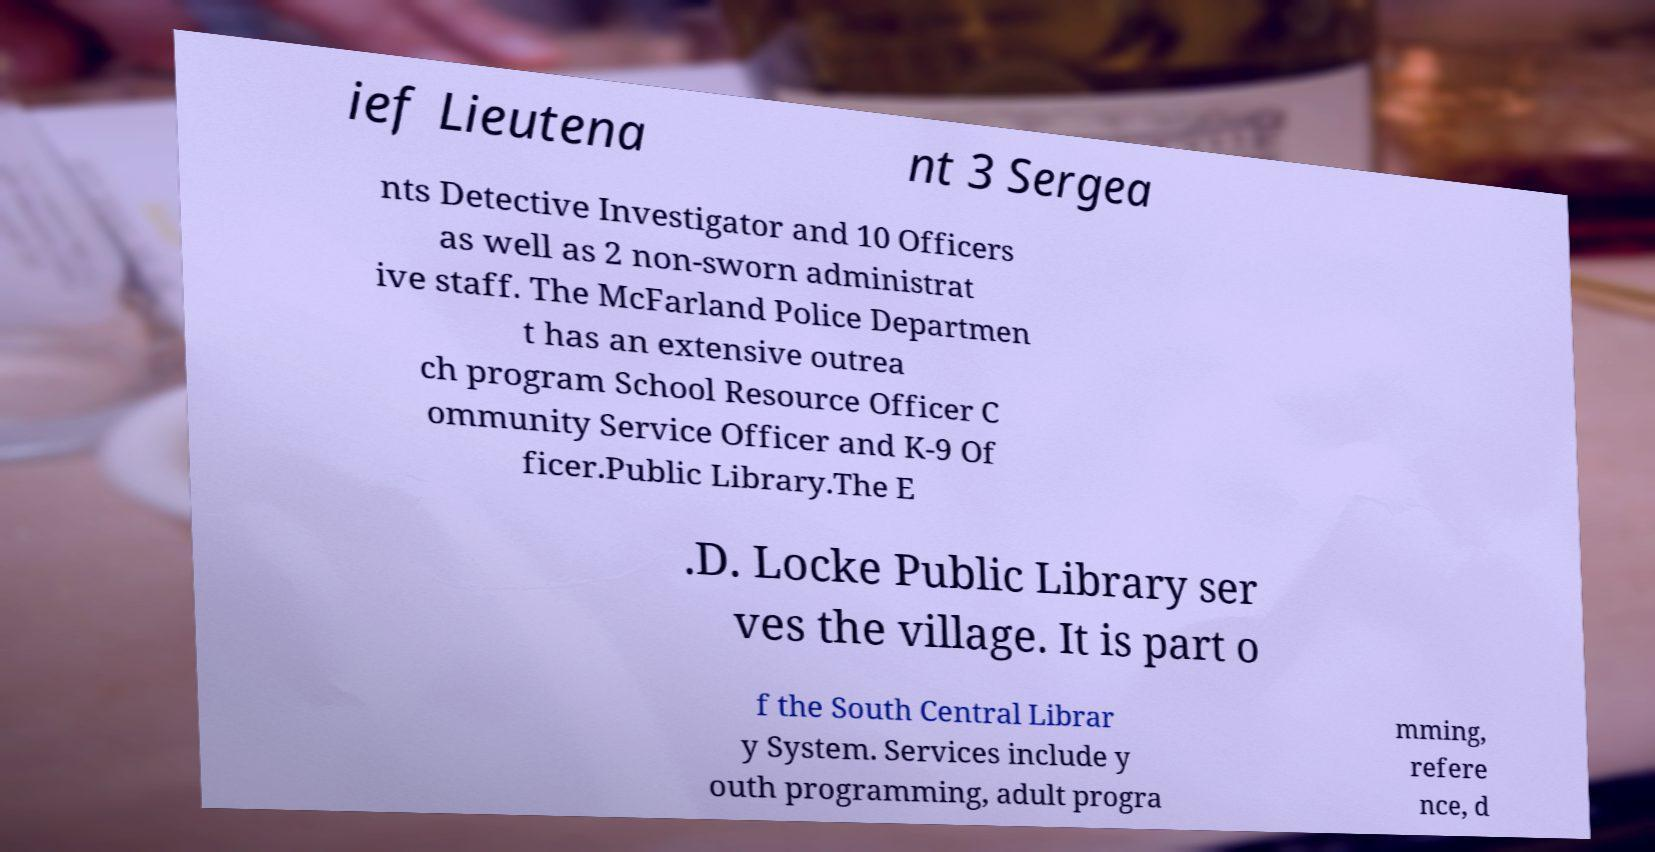I need the written content from this picture converted into text. Can you do that? ief Lieutena nt 3 Sergea nts Detective Investigator and 10 Officers as well as 2 non-sworn administrat ive staff. The McFarland Police Departmen t has an extensive outrea ch program School Resource Officer C ommunity Service Officer and K-9 Of ficer.Public Library.The E .D. Locke Public Library ser ves the village. It is part o f the South Central Librar y System. Services include y outh programming, adult progra mming, refere nce, d 